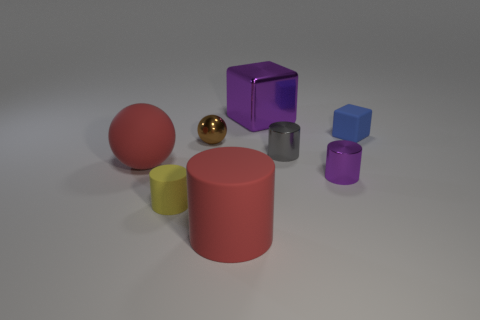Add 2 tiny gray cylinders. How many objects exist? 10 Subtract all big red rubber cylinders. How many cylinders are left? 3 Subtract all yellow cylinders. How many cylinders are left? 3 Subtract 2 cylinders. How many cylinders are left? 2 Subtract all cyan rubber blocks. Subtract all large red things. How many objects are left? 6 Add 4 metal spheres. How many metal spheres are left? 5 Add 8 red matte balls. How many red matte balls exist? 9 Subtract 0 brown cylinders. How many objects are left? 8 Subtract all red cubes. Subtract all brown cylinders. How many cubes are left? 2 